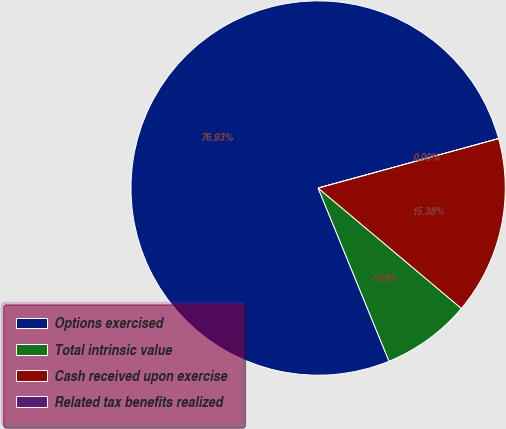<chart> <loc_0><loc_0><loc_500><loc_500><pie_chart><fcel>Options exercised<fcel>Total intrinsic value<fcel>Cash received upon exercise<fcel>Related tax benefits realized<nl><fcel>76.92%<fcel>7.69%<fcel>15.38%<fcel>0.0%<nl></chart> 